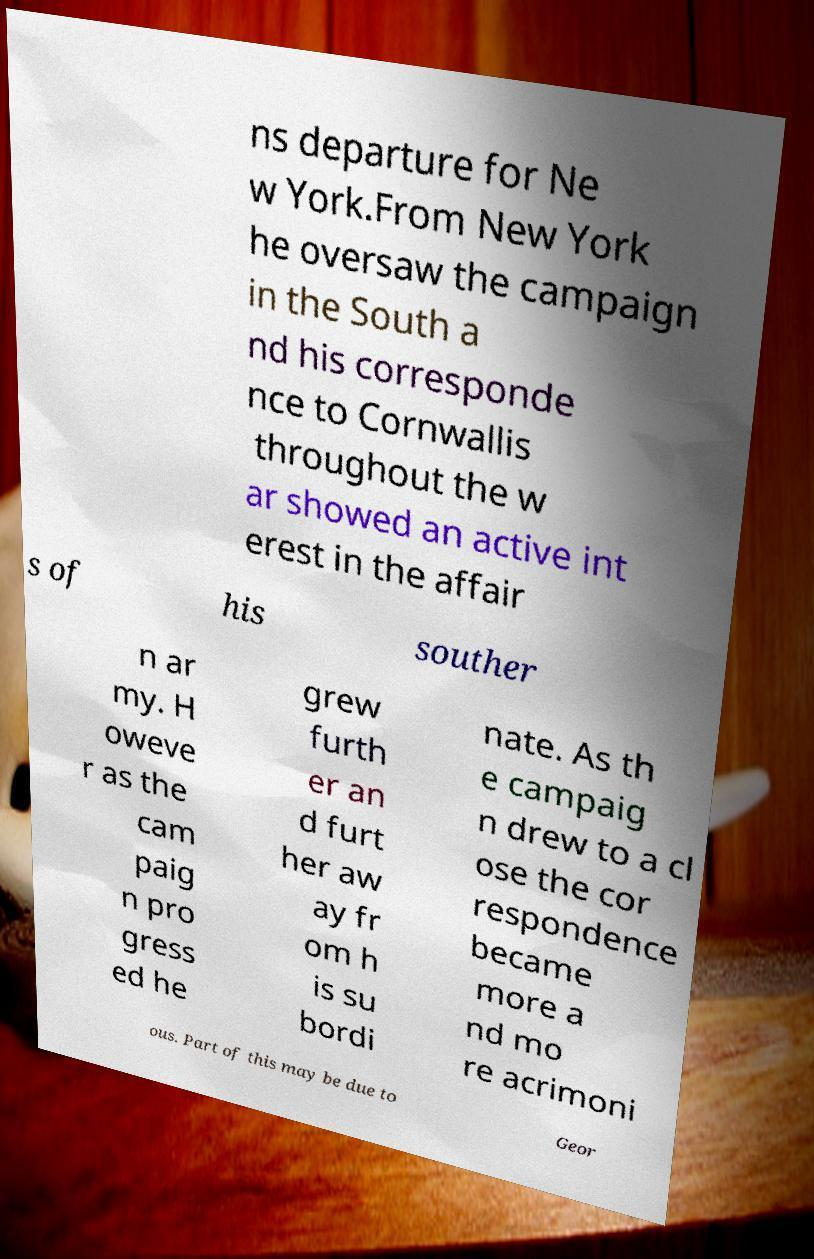Could you assist in decoding the text presented in this image and type it out clearly? ns departure for Ne w York.From New York he oversaw the campaign in the South a nd his corresponde nce to Cornwallis throughout the w ar showed an active int erest in the affair s of his souther n ar my. H oweve r as the cam paig n pro gress ed he grew furth er an d furt her aw ay fr om h is su bordi nate. As th e campaig n drew to a cl ose the cor respondence became more a nd mo re acrimoni ous. Part of this may be due to Geor 